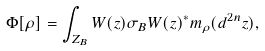Convert formula to latex. <formula><loc_0><loc_0><loc_500><loc_500>\Phi [ \rho ] = \int _ { Z _ { B } } W ( z ) \sigma _ { B } W ( z ) ^ { \ast } m _ { \rho } ( d ^ { 2 n } z ) ,</formula> 